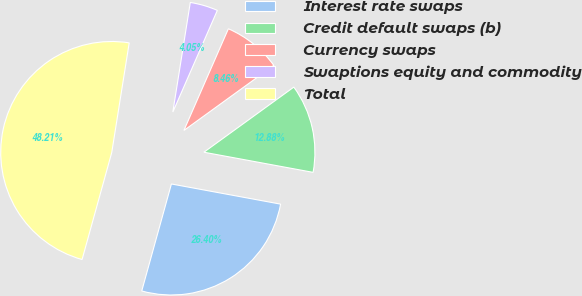Convert chart. <chart><loc_0><loc_0><loc_500><loc_500><pie_chart><fcel>Interest rate swaps<fcel>Credit default swaps (b)<fcel>Currency swaps<fcel>Swaptions equity and commodity<fcel>Total<nl><fcel>26.4%<fcel>12.88%<fcel>8.46%<fcel>4.05%<fcel>48.21%<nl></chart> 